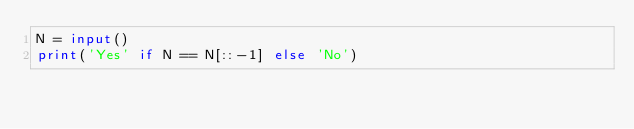Convert code to text. <code><loc_0><loc_0><loc_500><loc_500><_Python_>N = input()
print('Yes' if N == N[::-1] else 'No')
</code> 